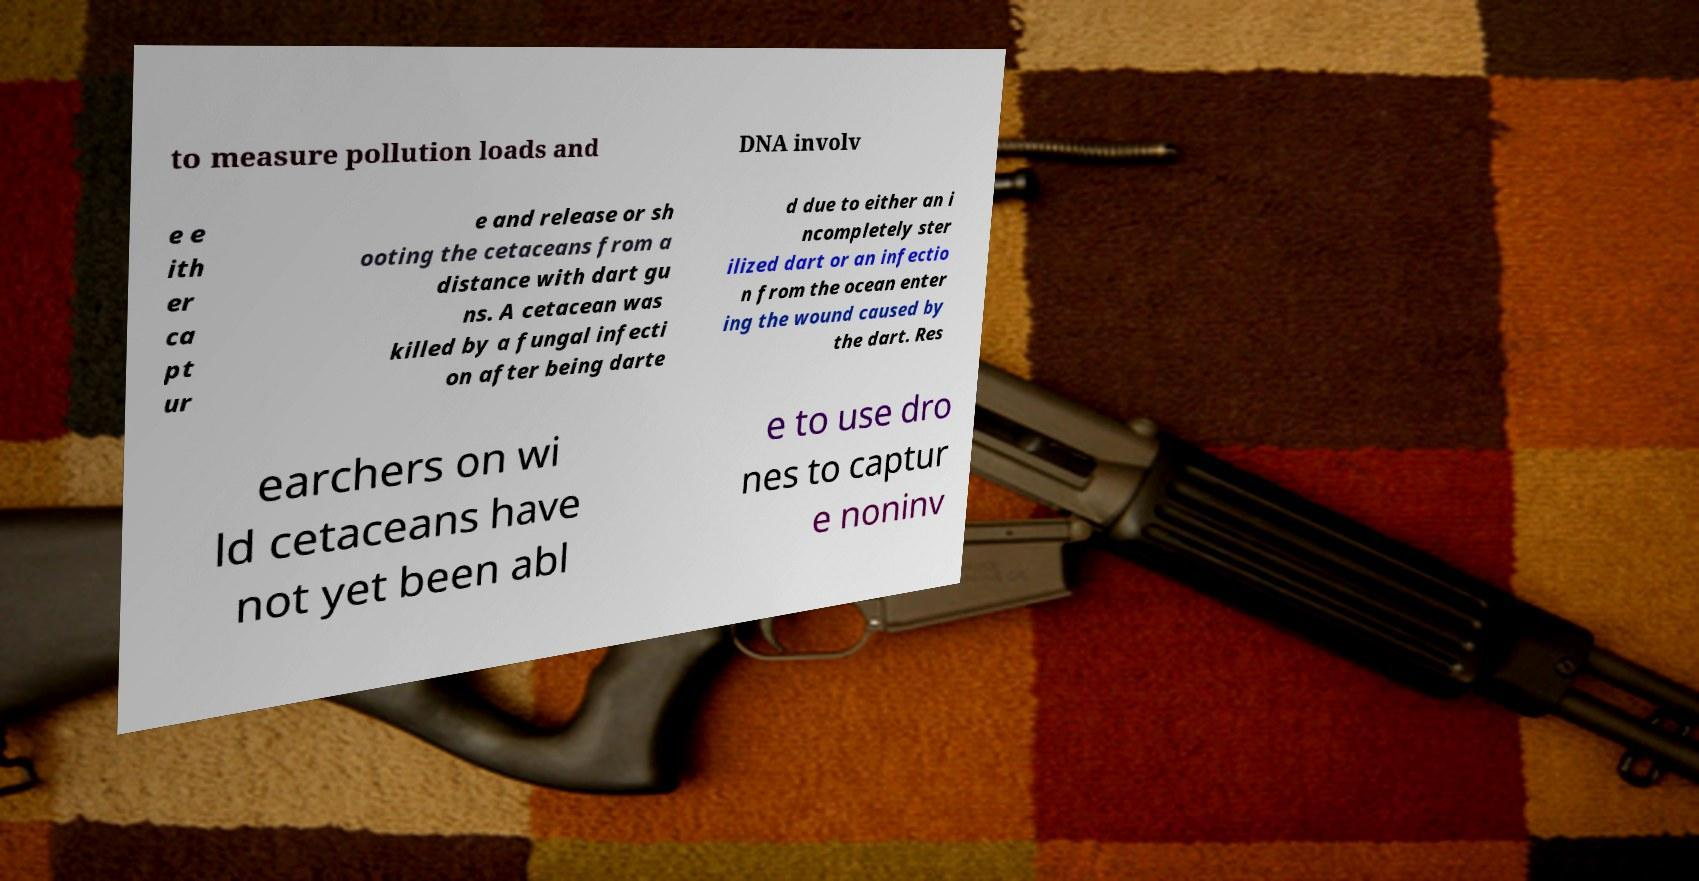Can you read and provide the text displayed in the image?This photo seems to have some interesting text. Can you extract and type it out for me? to measure pollution loads and DNA involv e e ith er ca pt ur e and release or sh ooting the cetaceans from a distance with dart gu ns. A cetacean was killed by a fungal infecti on after being darte d due to either an i ncompletely ster ilized dart or an infectio n from the ocean enter ing the wound caused by the dart. Res earchers on wi ld cetaceans have not yet been abl e to use dro nes to captur e noninv 